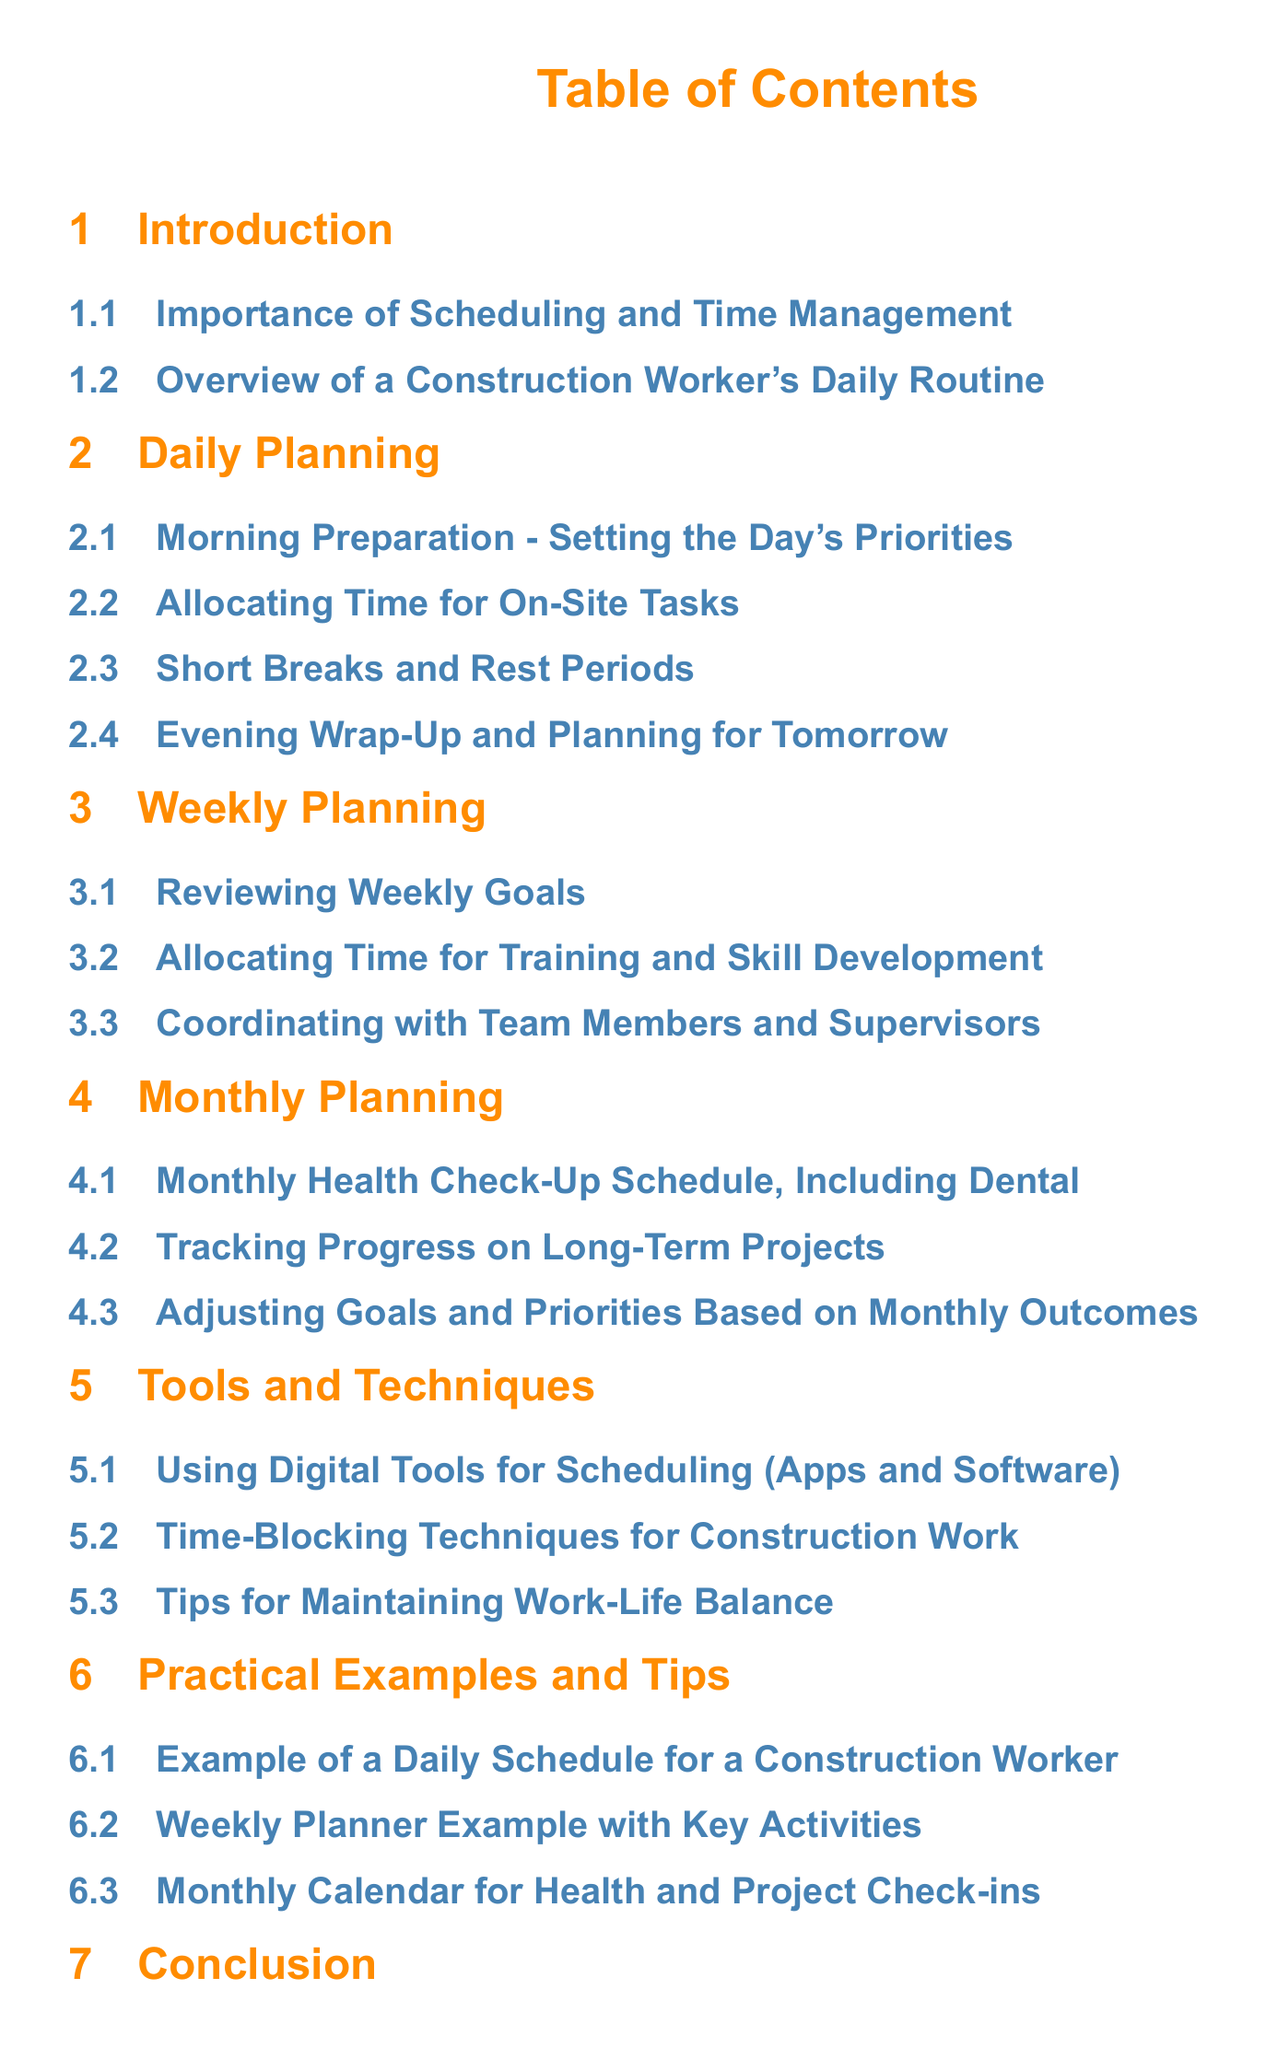what is the main focus of the document? The main focus is on Scheduling and Time Management for a Construction Worker, detailing daily, weekly, and monthly planning.
Answer: Scheduling and Time Management how many sections are in the Table of Contents? The Table of Contents has 7 main sections, including the Introduction and Conclusion.
Answer: 7 what is one of the topics covered in Monthly Planning? One of the topics covered is the Monthly Health Check-Up Schedule, Including Dental.
Answer: Monthly Health Check-Up Schedule, Including Dental which section addresses Work-Life Balance? The section that addresses Work-Life Balance is titled Tips for Maintaining Work-Life Balance.
Answer: Tips for Maintaining Work-Life Balance what does the document encourage regarding health? The document encourages prioritizing health check-ups.
Answer: Prioritize health check-ups what specific technique is mentioned for scheduling in construction work? The document mentions Time-Blocking Techniques for Construction Work as a specific technique.
Answer: Time-Blocking Techniques which subsection focuses on preparing for the next day? The subsection focusing on preparing for the next day is Evening Wrap-Up and Planning for Tomorrow.
Answer: Evening Wrap-Up and Planning for Tomorrow how often should a construction worker review their weekly goals? A construction worker should review their weekly goals on a weekly basis.
Answer: Weekly basis 